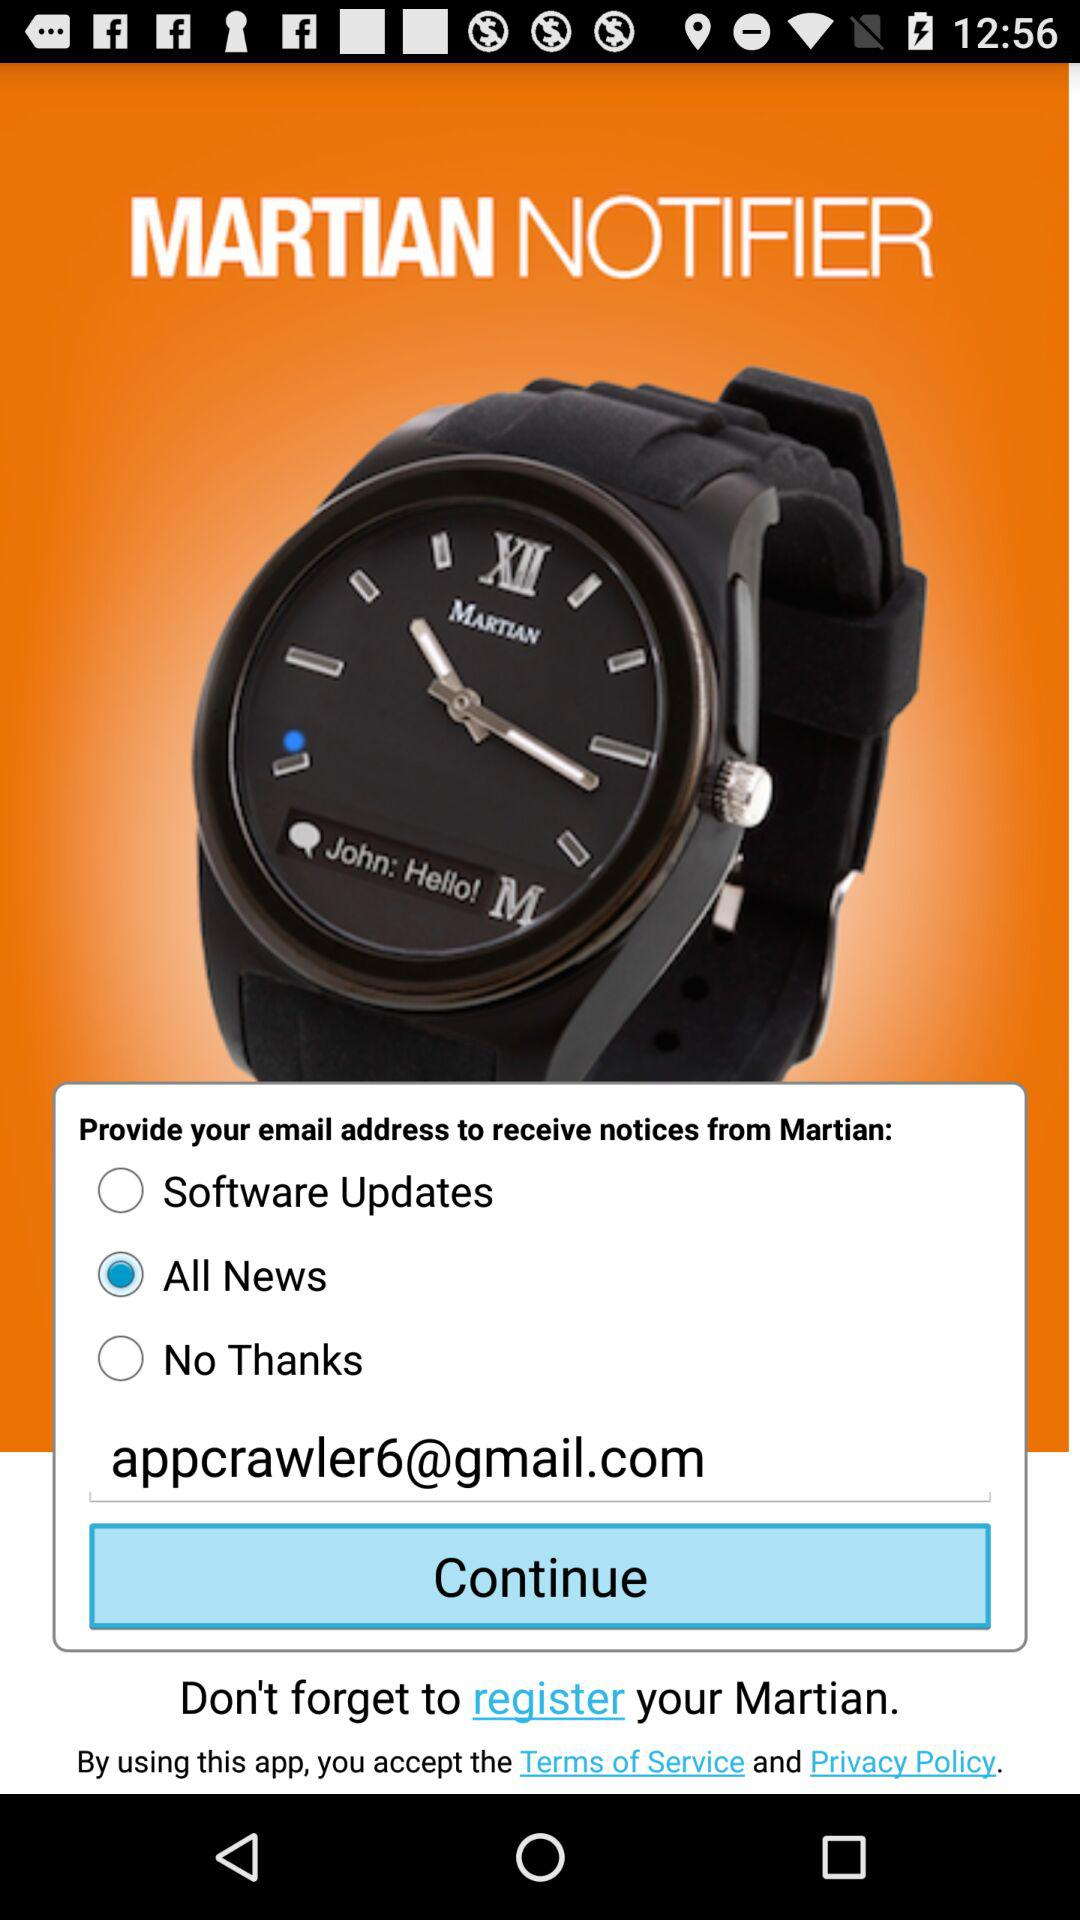Is "All News" selected or not? "All News" is selected. 